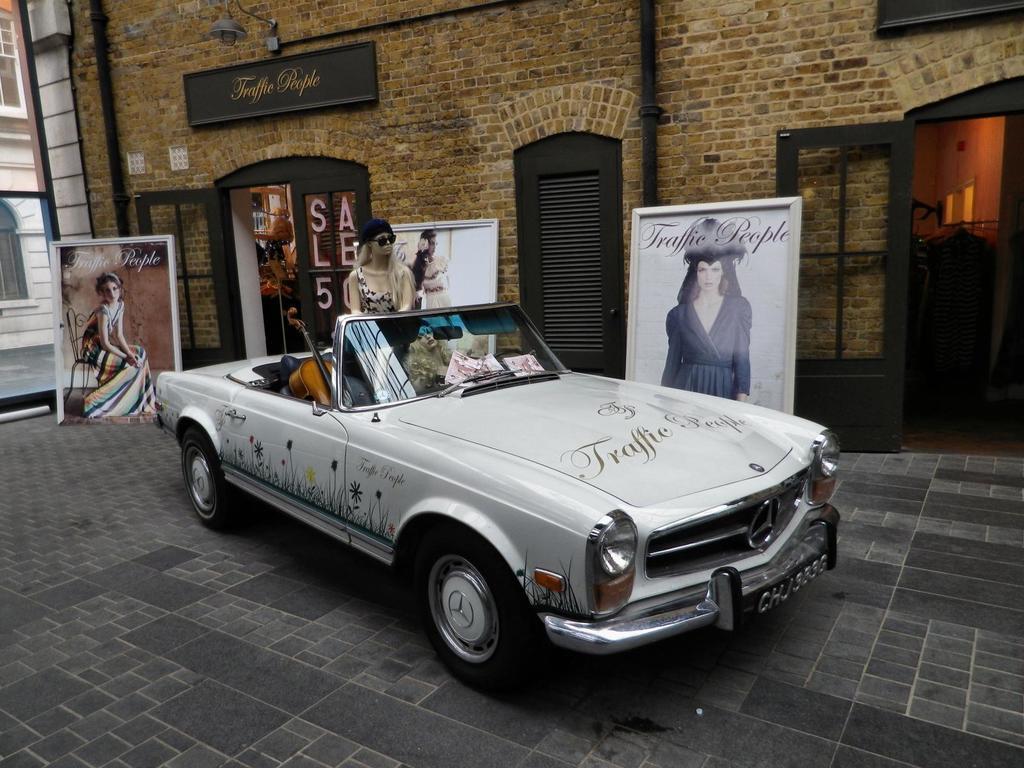Could you give a brief overview of what you see in this image? As we can see in the image there is a building, door, banner, a woman standing over here and there is a car. In car there is a guitar. 